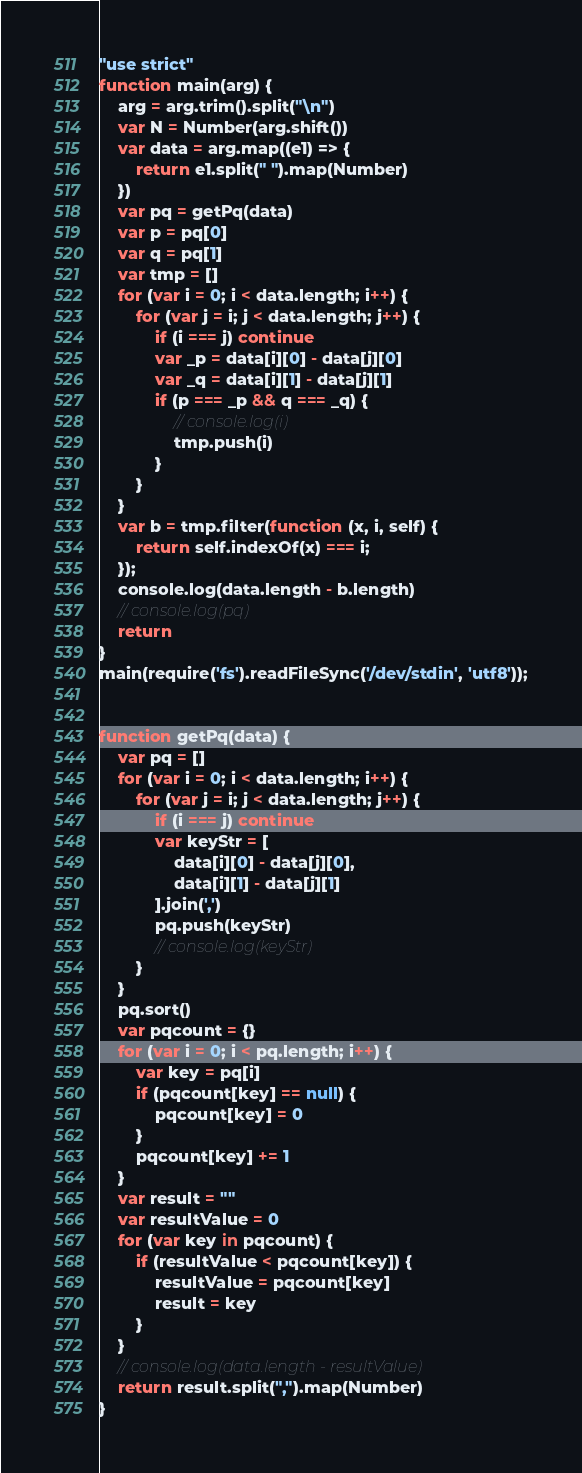Convert code to text. <code><loc_0><loc_0><loc_500><loc_500><_JavaScript_>"use strict"
function main(arg) {
    arg = arg.trim().split("\n")
    var N = Number(arg.shift())
    var data = arg.map((e1) => {
        return e1.split(" ").map(Number)
    })
    var pq = getPq(data)
    var p = pq[0]
    var q = pq[1]
    var tmp = []
    for (var i = 0; i < data.length; i++) {
        for (var j = i; j < data.length; j++) {
            if (i === j) continue
            var _p = data[i][0] - data[j][0]
            var _q = data[i][1] - data[j][1]
            if (p === _p && q === _q) {
                // console.log(i)
                tmp.push(i)
            }
        }
    }
    var b = tmp.filter(function (x, i, self) {
        return self.indexOf(x) === i;
    });
    console.log(data.length - b.length)
    // console.log(pq)
    return
}
main(require('fs').readFileSync('/dev/stdin', 'utf8'));


function getPq(data) {
    var pq = []
    for (var i = 0; i < data.length; i++) {
        for (var j = i; j < data.length; j++) {
            if (i === j) continue
            var keyStr = [
                data[i][0] - data[j][0],
                data[i][1] - data[j][1]
            ].join(',')
            pq.push(keyStr)
            // console.log(keyStr)
        }
    }
    pq.sort()
    var pqcount = {}
    for (var i = 0; i < pq.length; i++) {
        var key = pq[i]
        if (pqcount[key] == null) {
            pqcount[key] = 0
        }
        pqcount[key] += 1
    }
    var result = ""
    var resultValue = 0
    for (var key in pqcount) {
        if (resultValue < pqcount[key]) {
            resultValue = pqcount[key]
            result = key
        }
    }
    // console.log(data.length - resultValue)
    return result.split(",").map(Number)
}
</code> 